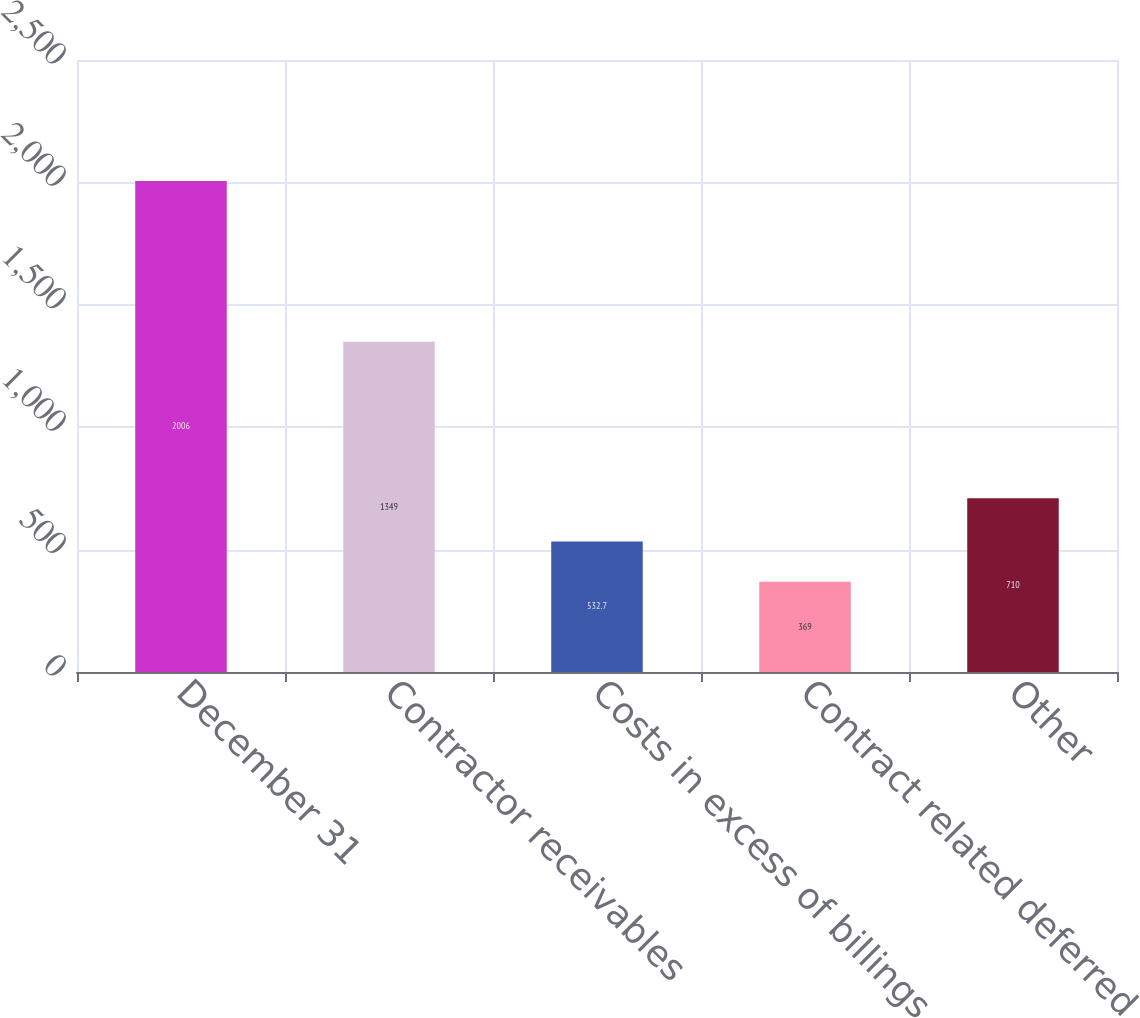<chart> <loc_0><loc_0><loc_500><loc_500><bar_chart><fcel>December 31<fcel>Contractor receivables<fcel>Costs in excess of billings<fcel>Contract related deferred<fcel>Other<nl><fcel>2006<fcel>1349<fcel>532.7<fcel>369<fcel>710<nl></chart> 